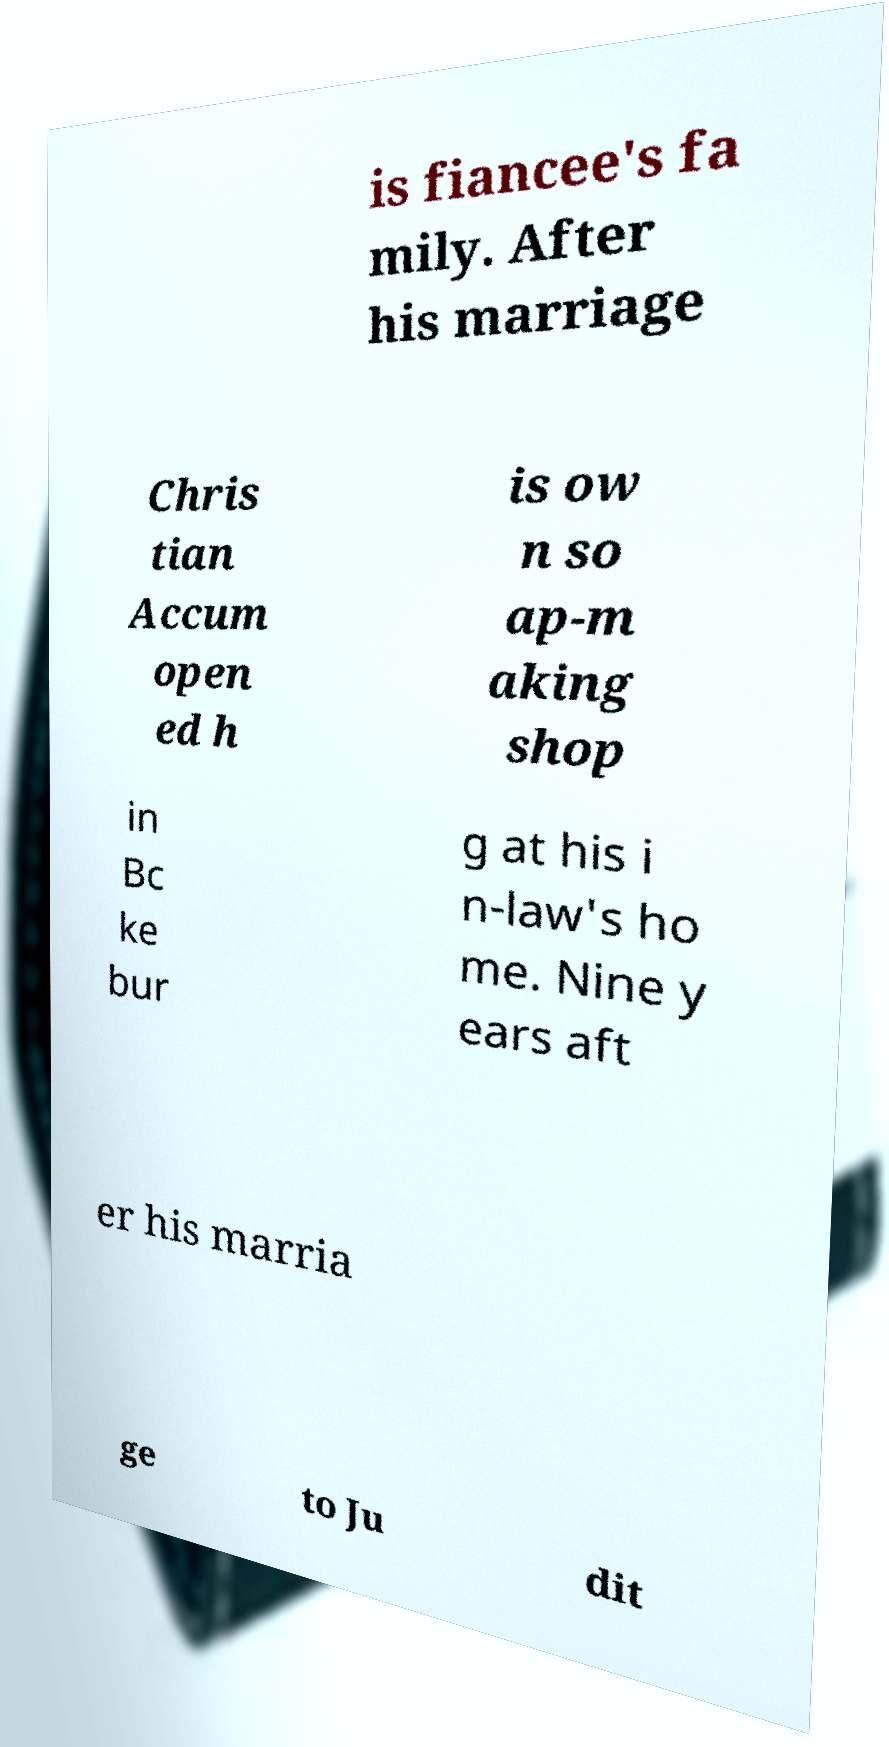Could you assist in decoding the text presented in this image and type it out clearly? is fiancee's fa mily. After his marriage Chris tian Accum open ed h is ow n so ap-m aking shop in Bc ke bur g at his i n-law's ho me. Nine y ears aft er his marria ge to Ju dit 